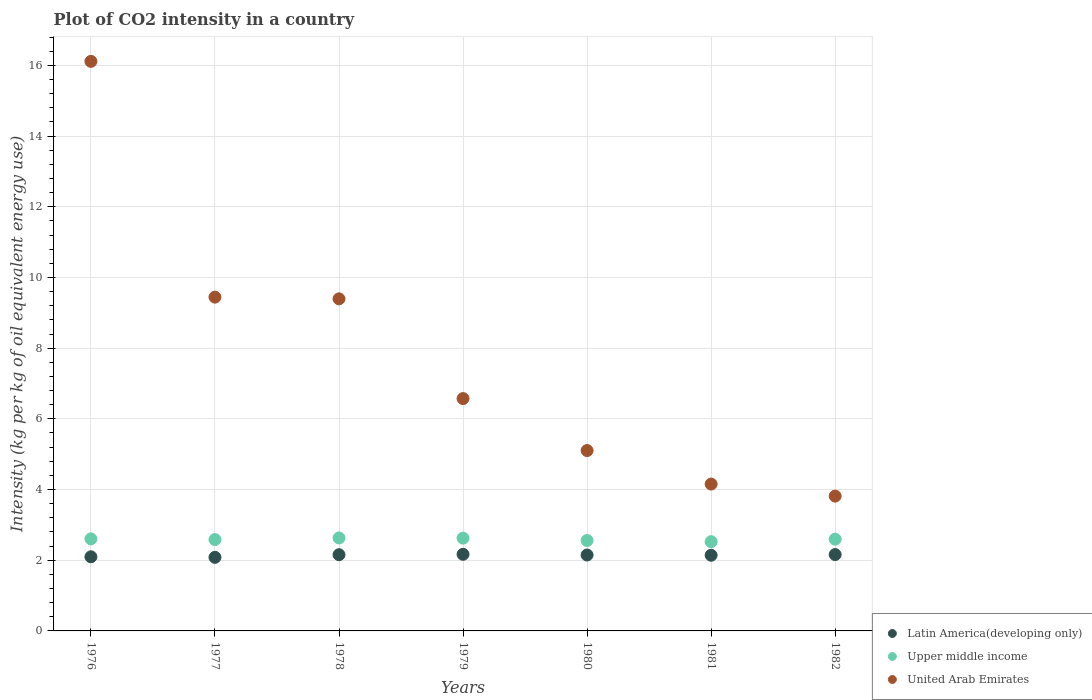Is the number of dotlines equal to the number of legend labels?
Give a very brief answer. Yes. What is the CO2 intensity in in United Arab Emirates in 1981?
Your answer should be compact. 4.15. Across all years, what is the maximum CO2 intensity in in United Arab Emirates?
Keep it short and to the point. 16.11. Across all years, what is the minimum CO2 intensity in in Latin America(developing only)?
Give a very brief answer. 2.08. In which year was the CO2 intensity in in Upper middle income maximum?
Offer a very short reply. 1978. What is the total CO2 intensity in in Latin America(developing only) in the graph?
Provide a short and direct response. 14.95. What is the difference between the CO2 intensity in in Upper middle income in 1976 and that in 1982?
Your answer should be compact. 0.01. What is the difference between the CO2 intensity in in Latin America(developing only) in 1978 and the CO2 intensity in in United Arab Emirates in 1977?
Ensure brevity in your answer.  -7.29. What is the average CO2 intensity in in Latin America(developing only) per year?
Offer a very short reply. 2.14. In the year 1978, what is the difference between the CO2 intensity in in Latin America(developing only) and CO2 intensity in in United Arab Emirates?
Offer a very short reply. -7.24. What is the ratio of the CO2 intensity in in Latin America(developing only) in 1980 to that in 1981?
Provide a short and direct response. 1. Is the CO2 intensity in in United Arab Emirates in 1978 less than that in 1979?
Make the answer very short. No. What is the difference between the highest and the second highest CO2 intensity in in Latin America(developing only)?
Give a very brief answer. 0.01. What is the difference between the highest and the lowest CO2 intensity in in Latin America(developing only)?
Provide a short and direct response. 0.09. In how many years, is the CO2 intensity in in Latin America(developing only) greater than the average CO2 intensity in in Latin America(developing only) taken over all years?
Give a very brief answer. 5. Is the sum of the CO2 intensity in in Upper middle income in 1976 and 1980 greater than the maximum CO2 intensity in in Latin America(developing only) across all years?
Offer a terse response. Yes. Does the CO2 intensity in in Upper middle income monotonically increase over the years?
Ensure brevity in your answer.  No. What is the difference between two consecutive major ticks on the Y-axis?
Your answer should be very brief. 2. Are the values on the major ticks of Y-axis written in scientific E-notation?
Make the answer very short. No. Where does the legend appear in the graph?
Keep it short and to the point. Bottom right. How many legend labels are there?
Offer a terse response. 3. How are the legend labels stacked?
Keep it short and to the point. Vertical. What is the title of the graph?
Offer a terse response. Plot of CO2 intensity in a country. Does "New Caledonia" appear as one of the legend labels in the graph?
Provide a short and direct response. No. What is the label or title of the X-axis?
Your answer should be compact. Years. What is the label or title of the Y-axis?
Your response must be concise. Intensity (kg per kg of oil equivalent energy use). What is the Intensity (kg per kg of oil equivalent energy use) in Latin America(developing only) in 1976?
Offer a terse response. 2.1. What is the Intensity (kg per kg of oil equivalent energy use) in Upper middle income in 1976?
Your answer should be very brief. 2.6. What is the Intensity (kg per kg of oil equivalent energy use) in United Arab Emirates in 1976?
Keep it short and to the point. 16.11. What is the Intensity (kg per kg of oil equivalent energy use) of Latin America(developing only) in 1977?
Provide a succinct answer. 2.08. What is the Intensity (kg per kg of oil equivalent energy use) of Upper middle income in 1977?
Keep it short and to the point. 2.58. What is the Intensity (kg per kg of oil equivalent energy use) of United Arab Emirates in 1977?
Offer a very short reply. 9.44. What is the Intensity (kg per kg of oil equivalent energy use) in Latin America(developing only) in 1978?
Your answer should be compact. 2.16. What is the Intensity (kg per kg of oil equivalent energy use) of Upper middle income in 1978?
Your response must be concise. 2.63. What is the Intensity (kg per kg of oil equivalent energy use) of United Arab Emirates in 1978?
Make the answer very short. 9.39. What is the Intensity (kg per kg of oil equivalent energy use) of Latin America(developing only) in 1979?
Give a very brief answer. 2.17. What is the Intensity (kg per kg of oil equivalent energy use) of Upper middle income in 1979?
Keep it short and to the point. 2.62. What is the Intensity (kg per kg of oil equivalent energy use) of United Arab Emirates in 1979?
Provide a succinct answer. 6.57. What is the Intensity (kg per kg of oil equivalent energy use) of Latin America(developing only) in 1980?
Provide a short and direct response. 2.15. What is the Intensity (kg per kg of oil equivalent energy use) of Upper middle income in 1980?
Keep it short and to the point. 2.56. What is the Intensity (kg per kg of oil equivalent energy use) in United Arab Emirates in 1980?
Keep it short and to the point. 5.1. What is the Intensity (kg per kg of oil equivalent energy use) of Latin America(developing only) in 1981?
Offer a terse response. 2.14. What is the Intensity (kg per kg of oil equivalent energy use) of Upper middle income in 1981?
Provide a succinct answer. 2.52. What is the Intensity (kg per kg of oil equivalent energy use) of United Arab Emirates in 1981?
Provide a short and direct response. 4.15. What is the Intensity (kg per kg of oil equivalent energy use) in Latin America(developing only) in 1982?
Provide a succinct answer. 2.16. What is the Intensity (kg per kg of oil equivalent energy use) in Upper middle income in 1982?
Your answer should be compact. 2.59. What is the Intensity (kg per kg of oil equivalent energy use) in United Arab Emirates in 1982?
Give a very brief answer. 3.81. Across all years, what is the maximum Intensity (kg per kg of oil equivalent energy use) in Latin America(developing only)?
Offer a very short reply. 2.17. Across all years, what is the maximum Intensity (kg per kg of oil equivalent energy use) in Upper middle income?
Provide a succinct answer. 2.63. Across all years, what is the maximum Intensity (kg per kg of oil equivalent energy use) in United Arab Emirates?
Offer a terse response. 16.11. Across all years, what is the minimum Intensity (kg per kg of oil equivalent energy use) in Latin America(developing only)?
Your answer should be compact. 2.08. Across all years, what is the minimum Intensity (kg per kg of oil equivalent energy use) in Upper middle income?
Your response must be concise. 2.52. Across all years, what is the minimum Intensity (kg per kg of oil equivalent energy use) of United Arab Emirates?
Offer a very short reply. 3.81. What is the total Intensity (kg per kg of oil equivalent energy use) of Latin America(developing only) in the graph?
Offer a terse response. 14.95. What is the total Intensity (kg per kg of oil equivalent energy use) of Upper middle income in the graph?
Offer a terse response. 18.12. What is the total Intensity (kg per kg of oil equivalent energy use) in United Arab Emirates in the graph?
Provide a short and direct response. 54.6. What is the difference between the Intensity (kg per kg of oil equivalent energy use) of Latin America(developing only) in 1976 and that in 1977?
Provide a short and direct response. 0.02. What is the difference between the Intensity (kg per kg of oil equivalent energy use) of Upper middle income in 1976 and that in 1977?
Your response must be concise. 0.02. What is the difference between the Intensity (kg per kg of oil equivalent energy use) in United Arab Emirates in 1976 and that in 1977?
Keep it short and to the point. 6.67. What is the difference between the Intensity (kg per kg of oil equivalent energy use) of Latin America(developing only) in 1976 and that in 1978?
Provide a succinct answer. -0.06. What is the difference between the Intensity (kg per kg of oil equivalent energy use) in Upper middle income in 1976 and that in 1978?
Ensure brevity in your answer.  -0.03. What is the difference between the Intensity (kg per kg of oil equivalent energy use) of United Arab Emirates in 1976 and that in 1978?
Your answer should be very brief. 6.72. What is the difference between the Intensity (kg per kg of oil equivalent energy use) of Latin America(developing only) in 1976 and that in 1979?
Your answer should be very brief. -0.07. What is the difference between the Intensity (kg per kg of oil equivalent energy use) of Upper middle income in 1976 and that in 1979?
Make the answer very short. -0.02. What is the difference between the Intensity (kg per kg of oil equivalent energy use) of United Arab Emirates in 1976 and that in 1979?
Ensure brevity in your answer.  9.54. What is the difference between the Intensity (kg per kg of oil equivalent energy use) of Latin America(developing only) in 1976 and that in 1980?
Make the answer very short. -0.05. What is the difference between the Intensity (kg per kg of oil equivalent energy use) in Upper middle income in 1976 and that in 1980?
Provide a short and direct response. 0.05. What is the difference between the Intensity (kg per kg of oil equivalent energy use) of United Arab Emirates in 1976 and that in 1980?
Ensure brevity in your answer.  11.01. What is the difference between the Intensity (kg per kg of oil equivalent energy use) of Latin America(developing only) in 1976 and that in 1981?
Offer a terse response. -0.04. What is the difference between the Intensity (kg per kg of oil equivalent energy use) in Upper middle income in 1976 and that in 1981?
Keep it short and to the point. 0.08. What is the difference between the Intensity (kg per kg of oil equivalent energy use) in United Arab Emirates in 1976 and that in 1981?
Ensure brevity in your answer.  11.96. What is the difference between the Intensity (kg per kg of oil equivalent energy use) of Latin America(developing only) in 1976 and that in 1982?
Provide a succinct answer. -0.06. What is the difference between the Intensity (kg per kg of oil equivalent energy use) in Upper middle income in 1976 and that in 1982?
Your answer should be compact. 0.01. What is the difference between the Intensity (kg per kg of oil equivalent energy use) in United Arab Emirates in 1976 and that in 1982?
Give a very brief answer. 12.3. What is the difference between the Intensity (kg per kg of oil equivalent energy use) of Latin America(developing only) in 1977 and that in 1978?
Give a very brief answer. -0.07. What is the difference between the Intensity (kg per kg of oil equivalent energy use) in Upper middle income in 1977 and that in 1978?
Your answer should be very brief. -0.05. What is the difference between the Intensity (kg per kg of oil equivalent energy use) in United Arab Emirates in 1977 and that in 1978?
Make the answer very short. 0.05. What is the difference between the Intensity (kg per kg of oil equivalent energy use) in Latin America(developing only) in 1977 and that in 1979?
Provide a succinct answer. -0.09. What is the difference between the Intensity (kg per kg of oil equivalent energy use) of Upper middle income in 1977 and that in 1979?
Keep it short and to the point. -0.04. What is the difference between the Intensity (kg per kg of oil equivalent energy use) in United Arab Emirates in 1977 and that in 1979?
Offer a terse response. 2.87. What is the difference between the Intensity (kg per kg of oil equivalent energy use) of Latin America(developing only) in 1977 and that in 1980?
Your response must be concise. -0.07. What is the difference between the Intensity (kg per kg of oil equivalent energy use) in Upper middle income in 1977 and that in 1980?
Keep it short and to the point. 0.03. What is the difference between the Intensity (kg per kg of oil equivalent energy use) in United Arab Emirates in 1977 and that in 1980?
Offer a terse response. 4.34. What is the difference between the Intensity (kg per kg of oil equivalent energy use) of Latin America(developing only) in 1977 and that in 1981?
Provide a short and direct response. -0.06. What is the difference between the Intensity (kg per kg of oil equivalent energy use) of Upper middle income in 1977 and that in 1981?
Provide a succinct answer. 0.06. What is the difference between the Intensity (kg per kg of oil equivalent energy use) of United Arab Emirates in 1977 and that in 1981?
Provide a short and direct response. 5.29. What is the difference between the Intensity (kg per kg of oil equivalent energy use) in Latin America(developing only) in 1977 and that in 1982?
Make the answer very short. -0.08. What is the difference between the Intensity (kg per kg of oil equivalent energy use) of Upper middle income in 1977 and that in 1982?
Keep it short and to the point. -0.01. What is the difference between the Intensity (kg per kg of oil equivalent energy use) of United Arab Emirates in 1977 and that in 1982?
Offer a very short reply. 5.63. What is the difference between the Intensity (kg per kg of oil equivalent energy use) in Latin America(developing only) in 1978 and that in 1979?
Make the answer very short. -0.01. What is the difference between the Intensity (kg per kg of oil equivalent energy use) of Upper middle income in 1978 and that in 1979?
Provide a short and direct response. 0.01. What is the difference between the Intensity (kg per kg of oil equivalent energy use) in United Arab Emirates in 1978 and that in 1979?
Keep it short and to the point. 2.82. What is the difference between the Intensity (kg per kg of oil equivalent energy use) in Latin America(developing only) in 1978 and that in 1980?
Ensure brevity in your answer.  0.01. What is the difference between the Intensity (kg per kg of oil equivalent energy use) of Upper middle income in 1978 and that in 1980?
Your response must be concise. 0.07. What is the difference between the Intensity (kg per kg of oil equivalent energy use) of United Arab Emirates in 1978 and that in 1980?
Make the answer very short. 4.29. What is the difference between the Intensity (kg per kg of oil equivalent energy use) of Latin America(developing only) in 1978 and that in 1981?
Keep it short and to the point. 0.02. What is the difference between the Intensity (kg per kg of oil equivalent energy use) in Upper middle income in 1978 and that in 1981?
Offer a very short reply. 0.11. What is the difference between the Intensity (kg per kg of oil equivalent energy use) of United Arab Emirates in 1978 and that in 1981?
Provide a succinct answer. 5.24. What is the difference between the Intensity (kg per kg of oil equivalent energy use) of Latin America(developing only) in 1978 and that in 1982?
Ensure brevity in your answer.  -0. What is the difference between the Intensity (kg per kg of oil equivalent energy use) in Upper middle income in 1978 and that in 1982?
Ensure brevity in your answer.  0.04. What is the difference between the Intensity (kg per kg of oil equivalent energy use) in United Arab Emirates in 1978 and that in 1982?
Your answer should be very brief. 5.58. What is the difference between the Intensity (kg per kg of oil equivalent energy use) of Latin America(developing only) in 1979 and that in 1980?
Keep it short and to the point. 0.02. What is the difference between the Intensity (kg per kg of oil equivalent energy use) in Upper middle income in 1979 and that in 1980?
Provide a succinct answer. 0.07. What is the difference between the Intensity (kg per kg of oil equivalent energy use) of United Arab Emirates in 1979 and that in 1980?
Offer a terse response. 1.47. What is the difference between the Intensity (kg per kg of oil equivalent energy use) in Latin America(developing only) in 1979 and that in 1981?
Your answer should be compact. 0.03. What is the difference between the Intensity (kg per kg of oil equivalent energy use) of Upper middle income in 1979 and that in 1981?
Give a very brief answer. 0.1. What is the difference between the Intensity (kg per kg of oil equivalent energy use) of United Arab Emirates in 1979 and that in 1981?
Offer a terse response. 2.42. What is the difference between the Intensity (kg per kg of oil equivalent energy use) of Latin America(developing only) in 1979 and that in 1982?
Provide a succinct answer. 0.01. What is the difference between the Intensity (kg per kg of oil equivalent energy use) of Upper middle income in 1979 and that in 1982?
Your answer should be very brief. 0.03. What is the difference between the Intensity (kg per kg of oil equivalent energy use) of United Arab Emirates in 1979 and that in 1982?
Give a very brief answer. 2.76. What is the difference between the Intensity (kg per kg of oil equivalent energy use) of Latin America(developing only) in 1980 and that in 1981?
Offer a terse response. 0.01. What is the difference between the Intensity (kg per kg of oil equivalent energy use) of Upper middle income in 1980 and that in 1981?
Your response must be concise. 0.03. What is the difference between the Intensity (kg per kg of oil equivalent energy use) of United Arab Emirates in 1980 and that in 1981?
Offer a terse response. 0.95. What is the difference between the Intensity (kg per kg of oil equivalent energy use) in Latin America(developing only) in 1980 and that in 1982?
Your response must be concise. -0.01. What is the difference between the Intensity (kg per kg of oil equivalent energy use) in Upper middle income in 1980 and that in 1982?
Keep it short and to the point. -0.04. What is the difference between the Intensity (kg per kg of oil equivalent energy use) of United Arab Emirates in 1980 and that in 1982?
Provide a short and direct response. 1.29. What is the difference between the Intensity (kg per kg of oil equivalent energy use) in Latin America(developing only) in 1981 and that in 1982?
Ensure brevity in your answer.  -0.02. What is the difference between the Intensity (kg per kg of oil equivalent energy use) of Upper middle income in 1981 and that in 1982?
Make the answer very short. -0.07. What is the difference between the Intensity (kg per kg of oil equivalent energy use) in United Arab Emirates in 1981 and that in 1982?
Ensure brevity in your answer.  0.34. What is the difference between the Intensity (kg per kg of oil equivalent energy use) in Latin America(developing only) in 1976 and the Intensity (kg per kg of oil equivalent energy use) in Upper middle income in 1977?
Provide a short and direct response. -0.49. What is the difference between the Intensity (kg per kg of oil equivalent energy use) in Latin America(developing only) in 1976 and the Intensity (kg per kg of oil equivalent energy use) in United Arab Emirates in 1977?
Keep it short and to the point. -7.35. What is the difference between the Intensity (kg per kg of oil equivalent energy use) of Upper middle income in 1976 and the Intensity (kg per kg of oil equivalent energy use) of United Arab Emirates in 1977?
Make the answer very short. -6.84. What is the difference between the Intensity (kg per kg of oil equivalent energy use) of Latin America(developing only) in 1976 and the Intensity (kg per kg of oil equivalent energy use) of Upper middle income in 1978?
Offer a very short reply. -0.53. What is the difference between the Intensity (kg per kg of oil equivalent energy use) in Latin America(developing only) in 1976 and the Intensity (kg per kg of oil equivalent energy use) in United Arab Emirates in 1978?
Your answer should be compact. -7.3. What is the difference between the Intensity (kg per kg of oil equivalent energy use) of Upper middle income in 1976 and the Intensity (kg per kg of oil equivalent energy use) of United Arab Emirates in 1978?
Provide a short and direct response. -6.79. What is the difference between the Intensity (kg per kg of oil equivalent energy use) in Latin America(developing only) in 1976 and the Intensity (kg per kg of oil equivalent energy use) in Upper middle income in 1979?
Provide a short and direct response. -0.53. What is the difference between the Intensity (kg per kg of oil equivalent energy use) in Latin America(developing only) in 1976 and the Intensity (kg per kg of oil equivalent energy use) in United Arab Emirates in 1979?
Your answer should be very brief. -4.48. What is the difference between the Intensity (kg per kg of oil equivalent energy use) of Upper middle income in 1976 and the Intensity (kg per kg of oil equivalent energy use) of United Arab Emirates in 1979?
Give a very brief answer. -3.97. What is the difference between the Intensity (kg per kg of oil equivalent energy use) of Latin America(developing only) in 1976 and the Intensity (kg per kg of oil equivalent energy use) of Upper middle income in 1980?
Your answer should be compact. -0.46. What is the difference between the Intensity (kg per kg of oil equivalent energy use) in Latin America(developing only) in 1976 and the Intensity (kg per kg of oil equivalent energy use) in United Arab Emirates in 1980?
Your response must be concise. -3.01. What is the difference between the Intensity (kg per kg of oil equivalent energy use) in Upper middle income in 1976 and the Intensity (kg per kg of oil equivalent energy use) in United Arab Emirates in 1980?
Your response must be concise. -2.5. What is the difference between the Intensity (kg per kg of oil equivalent energy use) in Latin America(developing only) in 1976 and the Intensity (kg per kg of oil equivalent energy use) in Upper middle income in 1981?
Provide a succinct answer. -0.43. What is the difference between the Intensity (kg per kg of oil equivalent energy use) of Latin America(developing only) in 1976 and the Intensity (kg per kg of oil equivalent energy use) of United Arab Emirates in 1981?
Provide a succinct answer. -2.06. What is the difference between the Intensity (kg per kg of oil equivalent energy use) of Upper middle income in 1976 and the Intensity (kg per kg of oil equivalent energy use) of United Arab Emirates in 1981?
Keep it short and to the point. -1.55. What is the difference between the Intensity (kg per kg of oil equivalent energy use) in Latin America(developing only) in 1976 and the Intensity (kg per kg of oil equivalent energy use) in Upper middle income in 1982?
Your answer should be very brief. -0.5. What is the difference between the Intensity (kg per kg of oil equivalent energy use) of Latin America(developing only) in 1976 and the Intensity (kg per kg of oil equivalent energy use) of United Arab Emirates in 1982?
Give a very brief answer. -1.72. What is the difference between the Intensity (kg per kg of oil equivalent energy use) in Upper middle income in 1976 and the Intensity (kg per kg of oil equivalent energy use) in United Arab Emirates in 1982?
Your response must be concise. -1.21. What is the difference between the Intensity (kg per kg of oil equivalent energy use) in Latin America(developing only) in 1977 and the Intensity (kg per kg of oil equivalent energy use) in Upper middle income in 1978?
Give a very brief answer. -0.55. What is the difference between the Intensity (kg per kg of oil equivalent energy use) in Latin America(developing only) in 1977 and the Intensity (kg per kg of oil equivalent energy use) in United Arab Emirates in 1978?
Provide a short and direct response. -7.31. What is the difference between the Intensity (kg per kg of oil equivalent energy use) of Upper middle income in 1977 and the Intensity (kg per kg of oil equivalent energy use) of United Arab Emirates in 1978?
Provide a short and direct response. -6.81. What is the difference between the Intensity (kg per kg of oil equivalent energy use) of Latin America(developing only) in 1977 and the Intensity (kg per kg of oil equivalent energy use) of Upper middle income in 1979?
Your response must be concise. -0.54. What is the difference between the Intensity (kg per kg of oil equivalent energy use) of Latin America(developing only) in 1977 and the Intensity (kg per kg of oil equivalent energy use) of United Arab Emirates in 1979?
Offer a terse response. -4.49. What is the difference between the Intensity (kg per kg of oil equivalent energy use) of Upper middle income in 1977 and the Intensity (kg per kg of oil equivalent energy use) of United Arab Emirates in 1979?
Offer a terse response. -3.99. What is the difference between the Intensity (kg per kg of oil equivalent energy use) of Latin America(developing only) in 1977 and the Intensity (kg per kg of oil equivalent energy use) of Upper middle income in 1980?
Your answer should be compact. -0.48. What is the difference between the Intensity (kg per kg of oil equivalent energy use) of Latin America(developing only) in 1977 and the Intensity (kg per kg of oil equivalent energy use) of United Arab Emirates in 1980?
Your response must be concise. -3.02. What is the difference between the Intensity (kg per kg of oil equivalent energy use) in Upper middle income in 1977 and the Intensity (kg per kg of oil equivalent energy use) in United Arab Emirates in 1980?
Offer a very short reply. -2.52. What is the difference between the Intensity (kg per kg of oil equivalent energy use) of Latin America(developing only) in 1977 and the Intensity (kg per kg of oil equivalent energy use) of Upper middle income in 1981?
Give a very brief answer. -0.44. What is the difference between the Intensity (kg per kg of oil equivalent energy use) in Latin America(developing only) in 1977 and the Intensity (kg per kg of oil equivalent energy use) in United Arab Emirates in 1981?
Your answer should be compact. -2.07. What is the difference between the Intensity (kg per kg of oil equivalent energy use) in Upper middle income in 1977 and the Intensity (kg per kg of oil equivalent energy use) in United Arab Emirates in 1981?
Provide a succinct answer. -1.57. What is the difference between the Intensity (kg per kg of oil equivalent energy use) of Latin America(developing only) in 1977 and the Intensity (kg per kg of oil equivalent energy use) of Upper middle income in 1982?
Provide a short and direct response. -0.51. What is the difference between the Intensity (kg per kg of oil equivalent energy use) in Latin America(developing only) in 1977 and the Intensity (kg per kg of oil equivalent energy use) in United Arab Emirates in 1982?
Offer a very short reply. -1.73. What is the difference between the Intensity (kg per kg of oil equivalent energy use) in Upper middle income in 1977 and the Intensity (kg per kg of oil equivalent energy use) in United Arab Emirates in 1982?
Your response must be concise. -1.23. What is the difference between the Intensity (kg per kg of oil equivalent energy use) in Latin America(developing only) in 1978 and the Intensity (kg per kg of oil equivalent energy use) in Upper middle income in 1979?
Your response must be concise. -0.47. What is the difference between the Intensity (kg per kg of oil equivalent energy use) of Latin America(developing only) in 1978 and the Intensity (kg per kg of oil equivalent energy use) of United Arab Emirates in 1979?
Your answer should be compact. -4.42. What is the difference between the Intensity (kg per kg of oil equivalent energy use) in Upper middle income in 1978 and the Intensity (kg per kg of oil equivalent energy use) in United Arab Emirates in 1979?
Your response must be concise. -3.94. What is the difference between the Intensity (kg per kg of oil equivalent energy use) of Latin America(developing only) in 1978 and the Intensity (kg per kg of oil equivalent energy use) of Upper middle income in 1980?
Make the answer very short. -0.4. What is the difference between the Intensity (kg per kg of oil equivalent energy use) in Latin America(developing only) in 1978 and the Intensity (kg per kg of oil equivalent energy use) in United Arab Emirates in 1980?
Provide a short and direct response. -2.95. What is the difference between the Intensity (kg per kg of oil equivalent energy use) of Upper middle income in 1978 and the Intensity (kg per kg of oil equivalent energy use) of United Arab Emirates in 1980?
Keep it short and to the point. -2.47. What is the difference between the Intensity (kg per kg of oil equivalent energy use) of Latin America(developing only) in 1978 and the Intensity (kg per kg of oil equivalent energy use) of Upper middle income in 1981?
Provide a succinct answer. -0.37. What is the difference between the Intensity (kg per kg of oil equivalent energy use) of Latin America(developing only) in 1978 and the Intensity (kg per kg of oil equivalent energy use) of United Arab Emirates in 1981?
Ensure brevity in your answer.  -2. What is the difference between the Intensity (kg per kg of oil equivalent energy use) in Upper middle income in 1978 and the Intensity (kg per kg of oil equivalent energy use) in United Arab Emirates in 1981?
Provide a short and direct response. -1.52. What is the difference between the Intensity (kg per kg of oil equivalent energy use) of Latin America(developing only) in 1978 and the Intensity (kg per kg of oil equivalent energy use) of Upper middle income in 1982?
Offer a very short reply. -0.44. What is the difference between the Intensity (kg per kg of oil equivalent energy use) in Latin America(developing only) in 1978 and the Intensity (kg per kg of oil equivalent energy use) in United Arab Emirates in 1982?
Offer a terse response. -1.66. What is the difference between the Intensity (kg per kg of oil equivalent energy use) in Upper middle income in 1978 and the Intensity (kg per kg of oil equivalent energy use) in United Arab Emirates in 1982?
Your answer should be very brief. -1.18. What is the difference between the Intensity (kg per kg of oil equivalent energy use) of Latin America(developing only) in 1979 and the Intensity (kg per kg of oil equivalent energy use) of Upper middle income in 1980?
Give a very brief answer. -0.39. What is the difference between the Intensity (kg per kg of oil equivalent energy use) in Latin America(developing only) in 1979 and the Intensity (kg per kg of oil equivalent energy use) in United Arab Emirates in 1980?
Ensure brevity in your answer.  -2.94. What is the difference between the Intensity (kg per kg of oil equivalent energy use) in Upper middle income in 1979 and the Intensity (kg per kg of oil equivalent energy use) in United Arab Emirates in 1980?
Offer a terse response. -2.48. What is the difference between the Intensity (kg per kg of oil equivalent energy use) of Latin America(developing only) in 1979 and the Intensity (kg per kg of oil equivalent energy use) of Upper middle income in 1981?
Your answer should be compact. -0.36. What is the difference between the Intensity (kg per kg of oil equivalent energy use) of Latin America(developing only) in 1979 and the Intensity (kg per kg of oil equivalent energy use) of United Arab Emirates in 1981?
Ensure brevity in your answer.  -1.99. What is the difference between the Intensity (kg per kg of oil equivalent energy use) of Upper middle income in 1979 and the Intensity (kg per kg of oil equivalent energy use) of United Arab Emirates in 1981?
Provide a short and direct response. -1.53. What is the difference between the Intensity (kg per kg of oil equivalent energy use) of Latin America(developing only) in 1979 and the Intensity (kg per kg of oil equivalent energy use) of Upper middle income in 1982?
Offer a very short reply. -0.43. What is the difference between the Intensity (kg per kg of oil equivalent energy use) in Latin America(developing only) in 1979 and the Intensity (kg per kg of oil equivalent energy use) in United Arab Emirates in 1982?
Make the answer very short. -1.65. What is the difference between the Intensity (kg per kg of oil equivalent energy use) of Upper middle income in 1979 and the Intensity (kg per kg of oil equivalent energy use) of United Arab Emirates in 1982?
Your response must be concise. -1.19. What is the difference between the Intensity (kg per kg of oil equivalent energy use) of Latin America(developing only) in 1980 and the Intensity (kg per kg of oil equivalent energy use) of Upper middle income in 1981?
Your answer should be very brief. -0.38. What is the difference between the Intensity (kg per kg of oil equivalent energy use) of Latin America(developing only) in 1980 and the Intensity (kg per kg of oil equivalent energy use) of United Arab Emirates in 1981?
Ensure brevity in your answer.  -2.01. What is the difference between the Intensity (kg per kg of oil equivalent energy use) in Upper middle income in 1980 and the Intensity (kg per kg of oil equivalent energy use) in United Arab Emirates in 1981?
Provide a succinct answer. -1.6. What is the difference between the Intensity (kg per kg of oil equivalent energy use) of Latin America(developing only) in 1980 and the Intensity (kg per kg of oil equivalent energy use) of Upper middle income in 1982?
Keep it short and to the point. -0.45. What is the difference between the Intensity (kg per kg of oil equivalent energy use) of Latin America(developing only) in 1980 and the Intensity (kg per kg of oil equivalent energy use) of United Arab Emirates in 1982?
Keep it short and to the point. -1.67. What is the difference between the Intensity (kg per kg of oil equivalent energy use) in Upper middle income in 1980 and the Intensity (kg per kg of oil equivalent energy use) in United Arab Emirates in 1982?
Your answer should be compact. -1.26. What is the difference between the Intensity (kg per kg of oil equivalent energy use) in Latin America(developing only) in 1981 and the Intensity (kg per kg of oil equivalent energy use) in Upper middle income in 1982?
Your answer should be compact. -0.45. What is the difference between the Intensity (kg per kg of oil equivalent energy use) in Latin America(developing only) in 1981 and the Intensity (kg per kg of oil equivalent energy use) in United Arab Emirates in 1982?
Keep it short and to the point. -1.67. What is the difference between the Intensity (kg per kg of oil equivalent energy use) in Upper middle income in 1981 and the Intensity (kg per kg of oil equivalent energy use) in United Arab Emirates in 1982?
Offer a very short reply. -1.29. What is the average Intensity (kg per kg of oil equivalent energy use) of Latin America(developing only) per year?
Your response must be concise. 2.14. What is the average Intensity (kg per kg of oil equivalent energy use) of Upper middle income per year?
Keep it short and to the point. 2.59. What is the average Intensity (kg per kg of oil equivalent energy use) of United Arab Emirates per year?
Offer a terse response. 7.8. In the year 1976, what is the difference between the Intensity (kg per kg of oil equivalent energy use) of Latin America(developing only) and Intensity (kg per kg of oil equivalent energy use) of Upper middle income?
Keep it short and to the point. -0.51. In the year 1976, what is the difference between the Intensity (kg per kg of oil equivalent energy use) of Latin America(developing only) and Intensity (kg per kg of oil equivalent energy use) of United Arab Emirates?
Offer a terse response. -14.02. In the year 1976, what is the difference between the Intensity (kg per kg of oil equivalent energy use) in Upper middle income and Intensity (kg per kg of oil equivalent energy use) in United Arab Emirates?
Offer a very short reply. -13.51. In the year 1977, what is the difference between the Intensity (kg per kg of oil equivalent energy use) of Latin America(developing only) and Intensity (kg per kg of oil equivalent energy use) of Upper middle income?
Offer a terse response. -0.5. In the year 1977, what is the difference between the Intensity (kg per kg of oil equivalent energy use) in Latin America(developing only) and Intensity (kg per kg of oil equivalent energy use) in United Arab Emirates?
Your response must be concise. -7.36. In the year 1977, what is the difference between the Intensity (kg per kg of oil equivalent energy use) of Upper middle income and Intensity (kg per kg of oil equivalent energy use) of United Arab Emirates?
Provide a succinct answer. -6.86. In the year 1978, what is the difference between the Intensity (kg per kg of oil equivalent energy use) of Latin America(developing only) and Intensity (kg per kg of oil equivalent energy use) of Upper middle income?
Your answer should be very brief. -0.47. In the year 1978, what is the difference between the Intensity (kg per kg of oil equivalent energy use) of Latin America(developing only) and Intensity (kg per kg of oil equivalent energy use) of United Arab Emirates?
Your answer should be very brief. -7.24. In the year 1978, what is the difference between the Intensity (kg per kg of oil equivalent energy use) in Upper middle income and Intensity (kg per kg of oil equivalent energy use) in United Arab Emirates?
Give a very brief answer. -6.76. In the year 1979, what is the difference between the Intensity (kg per kg of oil equivalent energy use) of Latin America(developing only) and Intensity (kg per kg of oil equivalent energy use) of Upper middle income?
Make the answer very short. -0.46. In the year 1979, what is the difference between the Intensity (kg per kg of oil equivalent energy use) of Latin America(developing only) and Intensity (kg per kg of oil equivalent energy use) of United Arab Emirates?
Give a very brief answer. -4.41. In the year 1979, what is the difference between the Intensity (kg per kg of oil equivalent energy use) of Upper middle income and Intensity (kg per kg of oil equivalent energy use) of United Arab Emirates?
Give a very brief answer. -3.95. In the year 1980, what is the difference between the Intensity (kg per kg of oil equivalent energy use) in Latin America(developing only) and Intensity (kg per kg of oil equivalent energy use) in Upper middle income?
Offer a very short reply. -0.41. In the year 1980, what is the difference between the Intensity (kg per kg of oil equivalent energy use) in Latin America(developing only) and Intensity (kg per kg of oil equivalent energy use) in United Arab Emirates?
Ensure brevity in your answer.  -2.96. In the year 1980, what is the difference between the Intensity (kg per kg of oil equivalent energy use) in Upper middle income and Intensity (kg per kg of oil equivalent energy use) in United Arab Emirates?
Your response must be concise. -2.54. In the year 1981, what is the difference between the Intensity (kg per kg of oil equivalent energy use) in Latin America(developing only) and Intensity (kg per kg of oil equivalent energy use) in Upper middle income?
Give a very brief answer. -0.38. In the year 1981, what is the difference between the Intensity (kg per kg of oil equivalent energy use) of Latin America(developing only) and Intensity (kg per kg of oil equivalent energy use) of United Arab Emirates?
Offer a very short reply. -2.01. In the year 1981, what is the difference between the Intensity (kg per kg of oil equivalent energy use) of Upper middle income and Intensity (kg per kg of oil equivalent energy use) of United Arab Emirates?
Offer a terse response. -1.63. In the year 1982, what is the difference between the Intensity (kg per kg of oil equivalent energy use) in Latin America(developing only) and Intensity (kg per kg of oil equivalent energy use) in Upper middle income?
Provide a succinct answer. -0.43. In the year 1982, what is the difference between the Intensity (kg per kg of oil equivalent energy use) in Latin America(developing only) and Intensity (kg per kg of oil equivalent energy use) in United Arab Emirates?
Provide a short and direct response. -1.65. In the year 1982, what is the difference between the Intensity (kg per kg of oil equivalent energy use) of Upper middle income and Intensity (kg per kg of oil equivalent energy use) of United Arab Emirates?
Provide a short and direct response. -1.22. What is the ratio of the Intensity (kg per kg of oil equivalent energy use) in Latin America(developing only) in 1976 to that in 1977?
Keep it short and to the point. 1.01. What is the ratio of the Intensity (kg per kg of oil equivalent energy use) of Upper middle income in 1976 to that in 1977?
Ensure brevity in your answer.  1.01. What is the ratio of the Intensity (kg per kg of oil equivalent energy use) of United Arab Emirates in 1976 to that in 1977?
Make the answer very short. 1.71. What is the ratio of the Intensity (kg per kg of oil equivalent energy use) of Latin America(developing only) in 1976 to that in 1978?
Your answer should be compact. 0.97. What is the ratio of the Intensity (kg per kg of oil equivalent energy use) in United Arab Emirates in 1976 to that in 1978?
Offer a very short reply. 1.72. What is the ratio of the Intensity (kg per kg of oil equivalent energy use) of Latin America(developing only) in 1976 to that in 1979?
Make the answer very short. 0.97. What is the ratio of the Intensity (kg per kg of oil equivalent energy use) in Upper middle income in 1976 to that in 1979?
Ensure brevity in your answer.  0.99. What is the ratio of the Intensity (kg per kg of oil equivalent energy use) in United Arab Emirates in 1976 to that in 1979?
Provide a succinct answer. 2.45. What is the ratio of the Intensity (kg per kg of oil equivalent energy use) in Latin America(developing only) in 1976 to that in 1980?
Keep it short and to the point. 0.98. What is the ratio of the Intensity (kg per kg of oil equivalent energy use) in Upper middle income in 1976 to that in 1980?
Your answer should be very brief. 1.02. What is the ratio of the Intensity (kg per kg of oil equivalent energy use) of United Arab Emirates in 1976 to that in 1980?
Your response must be concise. 3.16. What is the ratio of the Intensity (kg per kg of oil equivalent energy use) of Latin America(developing only) in 1976 to that in 1981?
Your answer should be compact. 0.98. What is the ratio of the Intensity (kg per kg of oil equivalent energy use) of Upper middle income in 1976 to that in 1981?
Ensure brevity in your answer.  1.03. What is the ratio of the Intensity (kg per kg of oil equivalent energy use) in United Arab Emirates in 1976 to that in 1981?
Offer a terse response. 3.88. What is the ratio of the Intensity (kg per kg of oil equivalent energy use) in Latin America(developing only) in 1976 to that in 1982?
Make the answer very short. 0.97. What is the ratio of the Intensity (kg per kg of oil equivalent energy use) in United Arab Emirates in 1976 to that in 1982?
Provide a succinct answer. 4.22. What is the ratio of the Intensity (kg per kg of oil equivalent energy use) in Latin America(developing only) in 1977 to that in 1978?
Make the answer very short. 0.97. What is the ratio of the Intensity (kg per kg of oil equivalent energy use) in Upper middle income in 1977 to that in 1978?
Your response must be concise. 0.98. What is the ratio of the Intensity (kg per kg of oil equivalent energy use) in United Arab Emirates in 1977 to that in 1978?
Your answer should be compact. 1.01. What is the ratio of the Intensity (kg per kg of oil equivalent energy use) of Latin America(developing only) in 1977 to that in 1979?
Provide a short and direct response. 0.96. What is the ratio of the Intensity (kg per kg of oil equivalent energy use) of United Arab Emirates in 1977 to that in 1979?
Keep it short and to the point. 1.44. What is the ratio of the Intensity (kg per kg of oil equivalent energy use) of Latin America(developing only) in 1977 to that in 1980?
Give a very brief answer. 0.97. What is the ratio of the Intensity (kg per kg of oil equivalent energy use) in Upper middle income in 1977 to that in 1980?
Your answer should be very brief. 1.01. What is the ratio of the Intensity (kg per kg of oil equivalent energy use) in United Arab Emirates in 1977 to that in 1980?
Offer a terse response. 1.85. What is the ratio of the Intensity (kg per kg of oil equivalent energy use) of Latin America(developing only) in 1977 to that in 1981?
Ensure brevity in your answer.  0.97. What is the ratio of the Intensity (kg per kg of oil equivalent energy use) of Upper middle income in 1977 to that in 1981?
Your answer should be compact. 1.02. What is the ratio of the Intensity (kg per kg of oil equivalent energy use) of United Arab Emirates in 1977 to that in 1981?
Make the answer very short. 2.27. What is the ratio of the Intensity (kg per kg of oil equivalent energy use) of Latin America(developing only) in 1977 to that in 1982?
Make the answer very short. 0.96. What is the ratio of the Intensity (kg per kg of oil equivalent energy use) in Upper middle income in 1977 to that in 1982?
Provide a short and direct response. 1. What is the ratio of the Intensity (kg per kg of oil equivalent energy use) of United Arab Emirates in 1977 to that in 1982?
Ensure brevity in your answer.  2.48. What is the ratio of the Intensity (kg per kg of oil equivalent energy use) in Latin America(developing only) in 1978 to that in 1979?
Ensure brevity in your answer.  0.99. What is the ratio of the Intensity (kg per kg of oil equivalent energy use) of United Arab Emirates in 1978 to that in 1979?
Offer a terse response. 1.43. What is the ratio of the Intensity (kg per kg of oil equivalent energy use) in Latin America(developing only) in 1978 to that in 1980?
Give a very brief answer. 1. What is the ratio of the Intensity (kg per kg of oil equivalent energy use) of Upper middle income in 1978 to that in 1980?
Ensure brevity in your answer.  1.03. What is the ratio of the Intensity (kg per kg of oil equivalent energy use) in United Arab Emirates in 1978 to that in 1980?
Keep it short and to the point. 1.84. What is the ratio of the Intensity (kg per kg of oil equivalent energy use) in Upper middle income in 1978 to that in 1981?
Keep it short and to the point. 1.04. What is the ratio of the Intensity (kg per kg of oil equivalent energy use) of United Arab Emirates in 1978 to that in 1981?
Ensure brevity in your answer.  2.26. What is the ratio of the Intensity (kg per kg of oil equivalent energy use) in Upper middle income in 1978 to that in 1982?
Your response must be concise. 1.01. What is the ratio of the Intensity (kg per kg of oil equivalent energy use) in United Arab Emirates in 1978 to that in 1982?
Give a very brief answer. 2.46. What is the ratio of the Intensity (kg per kg of oil equivalent energy use) of Latin America(developing only) in 1979 to that in 1980?
Provide a short and direct response. 1.01. What is the ratio of the Intensity (kg per kg of oil equivalent energy use) in Upper middle income in 1979 to that in 1980?
Offer a very short reply. 1.03. What is the ratio of the Intensity (kg per kg of oil equivalent energy use) of United Arab Emirates in 1979 to that in 1980?
Your response must be concise. 1.29. What is the ratio of the Intensity (kg per kg of oil equivalent energy use) in Latin America(developing only) in 1979 to that in 1981?
Give a very brief answer. 1.01. What is the ratio of the Intensity (kg per kg of oil equivalent energy use) in Upper middle income in 1979 to that in 1981?
Your answer should be compact. 1.04. What is the ratio of the Intensity (kg per kg of oil equivalent energy use) of United Arab Emirates in 1979 to that in 1981?
Keep it short and to the point. 1.58. What is the ratio of the Intensity (kg per kg of oil equivalent energy use) of Latin America(developing only) in 1979 to that in 1982?
Give a very brief answer. 1. What is the ratio of the Intensity (kg per kg of oil equivalent energy use) of Upper middle income in 1979 to that in 1982?
Offer a very short reply. 1.01. What is the ratio of the Intensity (kg per kg of oil equivalent energy use) of United Arab Emirates in 1979 to that in 1982?
Offer a terse response. 1.72. What is the ratio of the Intensity (kg per kg of oil equivalent energy use) in Latin America(developing only) in 1980 to that in 1981?
Your answer should be very brief. 1. What is the ratio of the Intensity (kg per kg of oil equivalent energy use) in Upper middle income in 1980 to that in 1981?
Offer a terse response. 1.01. What is the ratio of the Intensity (kg per kg of oil equivalent energy use) of United Arab Emirates in 1980 to that in 1981?
Give a very brief answer. 1.23. What is the ratio of the Intensity (kg per kg of oil equivalent energy use) in Latin America(developing only) in 1980 to that in 1982?
Provide a succinct answer. 0.99. What is the ratio of the Intensity (kg per kg of oil equivalent energy use) of United Arab Emirates in 1980 to that in 1982?
Make the answer very short. 1.34. What is the ratio of the Intensity (kg per kg of oil equivalent energy use) in Latin America(developing only) in 1981 to that in 1982?
Your response must be concise. 0.99. What is the ratio of the Intensity (kg per kg of oil equivalent energy use) in Upper middle income in 1981 to that in 1982?
Make the answer very short. 0.97. What is the ratio of the Intensity (kg per kg of oil equivalent energy use) in United Arab Emirates in 1981 to that in 1982?
Provide a short and direct response. 1.09. What is the difference between the highest and the second highest Intensity (kg per kg of oil equivalent energy use) of Latin America(developing only)?
Ensure brevity in your answer.  0.01. What is the difference between the highest and the second highest Intensity (kg per kg of oil equivalent energy use) of Upper middle income?
Keep it short and to the point. 0.01. What is the difference between the highest and the second highest Intensity (kg per kg of oil equivalent energy use) of United Arab Emirates?
Offer a terse response. 6.67. What is the difference between the highest and the lowest Intensity (kg per kg of oil equivalent energy use) in Latin America(developing only)?
Give a very brief answer. 0.09. What is the difference between the highest and the lowest Intensity (kg per kg of oil equivalent energy use) of Upper middle income?
Give a very brief answer. 0.11. What is the difference between the highest and the lowest Intensity (kg per kg of oil equivalent energy use) of United Arab Emirates?
Make the answer very short. 12.3. 